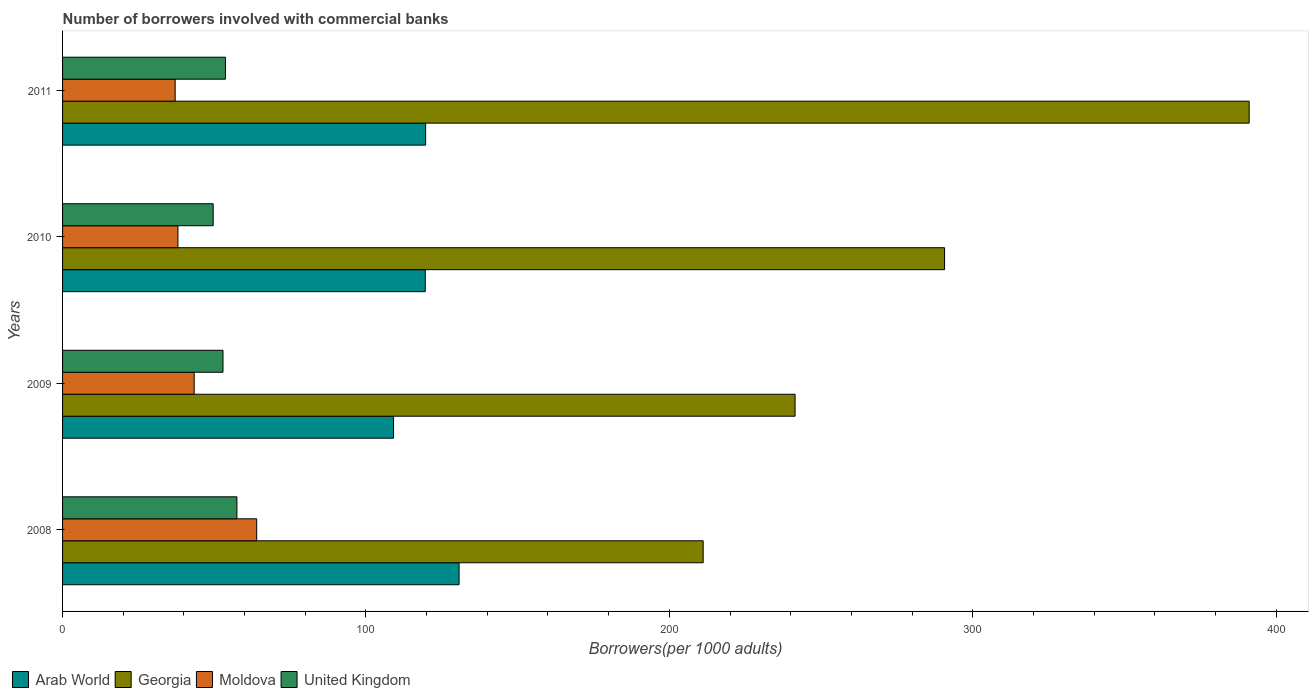How many different coloured bars are there?
Provide a short and direct response. 4. How many groups of bars are there?
Your answer should be very brief. 4. Are the number of bars on each tick of the Y-axis equal?
Your answer should be compact. Yes. How many bars are there on the 1st tick from the top?
Provide a succinct answer. 4. What is the label of the 2nd group of bars from the top?
Offer a very short reply. 2010. What is the number of borrowers involved with commercial banks in Georgia in 2009?
Provide a short and direct response. 241.45. Across all years, what is the maximum number of borrowers involved with commercial banks in Georgia?
Give a very brief answer. 391.13. Across all years, what is the minimum number of borrowers involved with commercial banks in Moldova?
Provide a short and direct response. 37.11. In which year was the number of borrowers involved with commercial banks in Georgia maximum?
Keep it short and to the point. 2011. What is the total number of borrowers involved with commercial banks in Georgia in the graph?
Make the answer very short. 1134.46. What is the difference between the number of borrowers involved with commercial banks in Arab World in 2010 and that in 2011?
Offer a very short reply. -0.13. What is the difference between the number of borrowers involved with commercial banks in Georgia in 2010 and the number of borrowers involved with commercial banks in Moldova in 2009?
Your answer should be compact. 247.35. What is the average number of borrowers involved with commercial banks in Moldova per year?
Your answer should be compact. 45.63. In the year 2010, what is the difference between the number of borrowers involved with commercial banks in Moldova and number of borrowers involved with commercial banks in Georgia?
Offer a terse response. -252.69. What is the ratio of the number of borrowers involved with commercial banks in Moldova in 2010 to that in 2011?
Your answer should be very brief. 1.02. Is the difference between the number of borrowers involved with commercial banks in Moldova in 2008 and 2010 greater than the difference between the number of borrowers involved with commercial banks in Georgia in 2008 and 2010?
Give a very brief answer. Yes. What is the difference between the highest and the second highest number of borrowers involved with commercial banks in Moldova?
Make the answer very short. 20.61. What is the difference between the highest and the lowest number of borrowers involved with commercial banks in Georgia?
Keep it short and to the point. 179.97. In how many years, is the number of borrowers involved with commercial banks in United Kingdom greater than the average number of borrowers involved with commercial banks in United Kingdom taken over all years?
Make the answer very short. 2. Is the sum of the number of borrowers involved with commercial banks in Georgia in 2008 and 2011 greater than the maximum number of borrowers involved with commercial banks in Arab World across all years?
Provide a succinct answer. Yes. What does the 3rd bar from the top in 2011 represents?
Offer a terse response. Georgia. What does the 2nd bar from the bottom in 2008 represents?
Offer a very short reply. Georgia. How many years are there in the graph?
Ensure brevity in your answer.  4. What is the difference between two consecutive major ticks on the X-axis?
Your answer should be very brief. 100. Does the graph contain any zero values?
Give a very brief answer. No. Does the graph contain grids?
Give a very brief answer. No. Where does the legend appear in the graph?
Your response must be concise. Bottom left. How many legend labels are there?
Your answer should be very brief. 4. What is the title of the graph?
Your answer should be compact. Number of borrowers involved with commercial banks. What is the label or title of the X-axis?
Ensure brevity in your answer.  Borrowers(per 1000 adults). What is the label or title of the Y-axis?
Keep it short and to the point. Years. What is the Borrowers(per 1000 adults) in Arab World in 2008?
Offer a terse response. 130.7. What is the Borrowers(per 1000 adults) of Georgia in 2008?
Keep it short and to the point. 211.16. What is the Borrowers(per 1000 adults) of Moldova in 2008?
Provide a succinct answer. 63.99. What is the Borrowers(per 1000 adults) in United Kingdom in 2008?
Ensure brevity in your answer.  57.47. What is the Borrowers(per 1000 adults) of Arab World in 2009?
Offer a very short reply. 109.1. What is the Borrowers(per 1000 adults) of Georgia in 2009?
Keep it short and to the point. 241.45. What is the Borrowers(per 1000 adults) of Moldova in 2009?
Ensure brevity in your answer.  43.38. What is the Borrowers(per 1000 adults) of United Kingdom in 2009?
Your response must be concise. 52.88. What is the Borrowers(per 1000 adults) of Arab World in 2010?
Keep it short and to the point. 119.55. What is the Borrowers(per 1000 adults) of Georgia in 2010?
Your response must be concise. 290.72. What is the Borrowers(per 1000 adults) in Moldova in 2010?
Your answer should be compact. 38.03. What is the Borrowers(per 1000 adults) in United Kingdom in 2010?
Offer a terse response. 49.65. What is the Borrowers(per 1000 adults) in Arab World in 2011?
Your answer should be very brief. 119.68. What is the Borrowers(per 1000 adults) of Georgia in 2011?
Your response must be concise. 391.13. What is the Borrowers(per 1000 adults) of Moldova in 2011?
Give a very brief answer. 37.11. What is the Borrowers(per 1000 adults) in United Kingdom in 2011?
Offer a very short reply. 53.68. Across all years, what is the maximum Borrowers(per 1000 adults) of Arab World?
Provide a succinct answer. 130.7. Across all years, what is the maximum Borrowers(per 1000 adults) in Georgia?
Your response must be concise. 391.13. Across all years, what is the maximum Borrowers(per 1000 adults) in Moldova?
Your response must be concise. 63.99. Across all years, what is the maximum Borrowers(per 1000 adults) in United Kingdom?
Provide a succinct answer. 57.47. Across all years, what is the minimum Borrowers(per 1000 adults) in Arab World?
Make the answer very short. 109.1. Across all years, what is the minimum Borrowers(per 1000 adults) in Georgia?
Offer a terse response. 211.16. Across all years, what is the minimum Borrowers(per 1000 adults) in Moldova?
Your response must be concise. 37.11. Across all years, what is the minimum Borrowers(per 1000 adults) in United Kingdom?
Make the answer very short. 49.65. What is the total Borrowers(per 1000 adults) of Arab World in the graph?
Provide a short and direct response. 479.02. What is the total Borrowers(per 1000 adults) in Georgia in the graph?
Provide a succinct answer. 1134.46. What is the total Borrowers(per 1000 adults) of Moldova in the graph?
Your response must be concise. 182.52. What is the total Borrowers(per 1000 adults) of United Kingdom in the graph?
Your answer should be compact. 213.68. What is the difference between the Borrowers(per 1000 adults) of Arab World in 2008 and that in 2009?
Ensure brevity in your answer.  21.6. What is the difference between the Borrowers(per 1000 adults) in Georgia in 2008 and that in 2009?
Your answer should be very brief. -30.29. What is the difference between the Borrowers(per 1000 adults) of Moldova in 2008 and that in 2009?
Your answer should be compact. 20.61. What is the difference between the Borrowers(per 1000 adults) in United Kingdom in 2008 and that in 2009?
Offer a terse response. 4.59. What is the difference between the Borrowers(per 1000 adults) of Arab World in 2008 and that in 2010?
Ensure brevity in your answer.  11.15. What is the difference between the Borrowers(per 1000 adults) in Georgia in 2008 and that in 2010?
Give a very brief answer. -79.56. What is the difference between the Borrowers(per 1000 adults) of Moldova in 2008 and that in 2010?
Offer a terse response. 25.95. What is the difference between the Borrowers(per 1000 adults) of United Kingdom in 2008 and that in 2010?
Keep it short and to the point. 7.83. What is the difference between the Borrowers(per 1000 adults) of Arab World in 2008 and that in 2011?
Give a very brief answer. 11.02. What is the difference between the Borrowers(per 1000 adults) in Georgia in 2008 and that in 2011?
Ensure brevity in your answer.  -179.97. What is the difference between the Borrowers(per 1000 adults) in Moldova in 2008 and that in 2011?
Offer a very short reply. 26.87. What is the difference between the Borrowers(per 1000 adults) of United Kingdom in 2008 and that in 2011?
Your answer should be very brief. 3.79. What is the difference between the Borrowers(per 1000 adults) of Arab World in 2009 and that in 2010?
Offer a terse response. -10.45. What is the difference between the Borrowers(per 1000 adults) of Georgia in 2009 and that in 2010?
Provide a short and direct response. -49.27. What is the difference between the Borrowers(per 1000 adults) of Moldova in 2009 and that in 2010?
Offer a terse response. 5.34. What is the difference between the Borrowers(per 1000 adults) of United Kingdom in 2009 and that in 2010?
Provide a short and direct response. 3.23. What is the difference between the Borrowers(per 1000 adults) of Arab World in 2009 and that in 2011?
Keep it short and to the point. -10.58. What is the difference between the Borrowers(per 1000 adults) of Georgia in 2009 and that in 2011?
Your response must be concise. -149.68. What is the difference between the Borrowers(per 1000 adults) of Moldova in 2009 and that in 2011?
Your answer should be very brief. 6.26. What is the difference between the Borrowers(per 1000 adults) in United Kingdom in 2009 and that in 2011?
Make the answer very short. -0.8. What is the difference between the Borrowers(per 1000 adults) in Arab World in 2010 and that in 2011?
Keep it short and to the point. -0.13. What is the difference between the Borrowers(per 1000 adults) of Georgia in 2010 and that in 2011?
Your answer should be very brief. -100.4. What is the difference between the Borrowers(per 1000 adults) of Moldova in 2010 and that in 2011?
Your response must be concise. 0.92. What is the difference between the Borrowers(per 1000 adults) of United Kingdom in 2010 and that in 2011?
Give a very brief answer. -4.03. What is the difference between the Borrowers(per 1000 adults) in Arab World in 2008 and the Borrowers(per 1000 adults) in Georgia in 2009?
Your answer should be compact. -110.75. What is the difference between the Borrowers(per 1000 adults) in Arab World in 2008 and the Borrowers(per 1000 adults) in Moldova in 2009?
Make the answer very short. 87.32. What is the difference between the Borrowers(per 1000 adults) of Arab World in 2008 and the Borrowers(per 1000 adults) of United Kingdom in 2009?
Provide a short and direct response. 77.82. What is the difference between the Borrowers(per 1000 adults) in Georgia in 2008 and the Borrowers(per 1000 adults) in Moldova in 2009?
Your answer should be compact. 167.78. What is the difference between the Borrowers(per 1000 adults) in Georgia in 2008 and the Borrowers(per 1000 adults) in United Kingdom in 2009?
Offer a terse response. 158.28. What is the difference between the Borrowers(per 1000 adults) in Moldova in 2008 and the Borrowers(per 1000 adults) in United Kingdom in 2009?
Ensure brevity in your answer.  11.11. What is the difference between the Borrowers(per 1000 adults) in Arab World in 2008 and the Borrowers(per 1000 adults) in Georgia in 2010?
Ensure brevity in your answer.  -160.03. What is the difference between the Borrowers(per 1000 adults) of Arab World in 2008 and the Borrowers(per 1000 adults) of Moldova in 2010?
Provide a short and direct response. 92.66. What is the difference between the Borrowers(per 1000 adults) of Arab World in 2008 and the Borrowers(per 1000 adults) of United Kingdom in 2010?
Your answer should be compact. 81.05. What is the difference between the Borrowers(per 1000 adults) in Georgia in 2008 and the Borrowers(per 1000 adults) in Moldova in 2010?
Your answer should be compact. 173.12. What is the difference between the Borrowers(per 1000 adults) in Georgia in 2008 and the Borrowers(per 1000 adults) in United Kingdom in 2010?
Ensure brevity in your answer.  161.51. What is the difference between the Borrowers(per 1000 adults) of Moldova in 2008 and the Borrowers(per 1000 adults) of United Kingdom in 2010?
Your response must be concise. 14.34. What is the difference between the Borrowers(per 1000 adults) of Arab World in 2008 and the Borrowers(per 1000 adults) of Georgia in 2011?
Make the answer very short. -260.43. What is the difference between the Borrowers(per 1000 adults) in Arab World in 2008 and the Borrowers(per 1000 adults) in Moldova in 2011?
Ensure brevity in your answer.  93.58. What is the difference between the Borrowers(per 1000 adults) of Arab World in 2008 and the Borrowers(per 1000 adults) of United Kingdom in 2011?
Your answer should be compact. 77.02. What is the difference between the Borrowers(per 1000 adults) of Georgia in 2008 and the Borrowers(per 1000 adults) of Moldova in 2011?
Your answer should be very brief. 174.05. What is the difference between the Borrowers(per 1000 adults) in Georgia in 2008 and the Borrowers(per 1000 adults) in United Kingdom in 2011?
Provide a short and direct response. 157.48. What is the difference between the Borrowers(per 1000 adults) in Moldova in 2008 and the Borrowers(per 1000 adults) in United Kingdom in 2011?
Give a very brief answer. 10.31. What is the difference between the Borrowers(per 1000 adults) of Arab World in 2009 and the Borrowers(per 1000 adults) of Georgia in 2010?
Ensure brevity in your answer.  -181.63. What is the difference between the Borrowers(per 1000 adults) of Arab World in 2009 and the Borrowers(per 1000 adults) of Moldova in 2010?
Ensure brevity in your answer.  71.06. What is the difference between the Borrowers(per 1000 adults) of Arab World in 2009 and the Borrowers(per 1000 adults) of United Kingdom in 2010?
Your response must be concise. 59.45. What is the difference between the Borrowers(per 1000 adults) of Georgia in 2009 and the Borrowers(per 1000 adults) of Moldova in 2010?
Offer a very short reply. 203.42. What is the difference between the Borrowers(per 1000 adults) in Georgia in 2009 and the Borrowers(per 1000 adults) in United Kingdom in 2010?
Your answer should be compact. 191.8. What is the difference between the Borrowers(per 1000 adults) of Moldova in 2009 and the Borrowers(per 1000 adults) of United Kingdom in 2010?
Offer a terse response. -6.27. What is the difference between the Borrowers(per 1000 adults) of Arab World in 2009 and the Borrowers(per 1000 adults) of Georgia in 2011?
Your answer should be very brief. -282.03. What is the difference between the Borrowers(per 1000 adults) in Arab World in 2009 and the Borrowers(per 1000 adults) in Moldova in 2011?
Provide a succinct answer. 71.98. What is the difference between the Borrowers(per 1000 adults) of Arab World in 2009 and the Borrowers(per 1000 adults) of United Kingdom in 2011?
Ensure brevity in your answer.  55.42. What is the difference between the Borrowers(per 1000 adults) of Georgia in 2009 and the Borrowers(per 1000 adults) of Moldova in 2011?
Make the answer very short. 204.34. What is the difference between the Borrowers(per 1000 adults) of Georgia in 2009 and the Borrowers(per 1000 adults) of United Kingdom in 2011?
Provide a succinct answer. 187.77. What is the difference between the Borrowers(per 1000 adults) of Moldova in 2009 and the Borrowers(per 1000 adults) of United Kingdom in 2011?
Offer a very short reply. -10.3. What is the difference between the Borrowers(per 1000 adults) in Arab World in 2010 and the Borrowers(per 1000 adults) in Georgia in 2011?
Ensure brevity in your answer.  -271.58. What is the difference between the Borrowers(per 1000 adults) of Arab World in 2010 and the Borrowers(per 1000 adults) of Moldova in 2011?
Keep it short and to the point. 82.43. What is the difference between the Borrowers(per 1000 adults) of Arab World in 2010 and the Borrowers(per 1000 adults) of United Kingdom in 2011?
Offer a very short reply. 65.87. What is the difference between the Borrowers(per 1000 adults) of Georgia in 2010 and the Borrowers(per 1000 adults) of Moldova in 2011?
Give a very brief answer. 253.61. What is the difference between the Borrowers(per 1000 adults) of Georgia in 2010 and the Borrowers(per 1000 adults) of United Kingdom in 2011?
Offer a very short reply. 237.04. What is the difference between the Borrowers(per 1000 adults) of Moldova in 2010 and the Borrowers(per 1000 adults) of United Kingdom in 2011?
Offer a very short reply. -15.64. What is the average Borrowers(per 1000 adults) of Arab World per year?
Offer a terse response. 119.76. What is the average Borrowers(per 1000 adults) in Georgia per year?
Your answer should be very brief. 283.62. What is the average Borrowers(per 1000 adults) in Moldova per year?
Your answer should be compact. 45.63. What is the average Borrowers(per 1000 adults) of United Kingdom per year?
Give a very brief answer. 53.42. In the year 2008, what is the difference between the Borrowers(per 1000 adults) in Arab World and Borrowers(per 1000 adults) in Georgia?
Your answer should be very brief. -80.46. In the year 2008, what is the difference between the Borrowers(per 1000 adults) in Arab World and Borrowers(per 1000 adults) in Moldova?
Your answer should be very brief. 66.71. In the year 2008, what is the difference between the Borrowers(per 1000 adults) in Arab World and Borrowers(per 1000 adults) in United Kingdom?
Keep it short and to the point. 73.22. In the year 2008, what is the difference between the Borrowers(per 1000 adults) in Georgia and Borrowers(per 1000 adults) in Moldova?
Give a very brief answer. 147.17. In the year 2008, what is the difference between the Borrowers(per 1000 adults) of Georgia and Borrowers(per 1000 adults) of United Kingdom?
Provide a short and direct response. 153.69. In the year 2008, what is the difference between the Borrowers(per 1000 adults) of Moldova and Borrowers(per 1000 adults) of United Kingdom?
Your answer should be very brief. 6.52. In the year 2009, what is the difference between the Borrowers(per 1000 adults) in Arab World and Borrowers(per 1000 adults) in Georgia?
Your response must be concise. -132.35. In the year 2009, what is the difference between the Borrowers(per 1000 adults) of Arab World and Borrowers(per 1000 adults) of Moldova?
Provide a succinct answer. 65.72. In the year 2009, what is the difference between the Borrowers(per 1000 adults) in Arab World and Borrowers(per 1000 adults) in United Kingdom?
Provide a short and direct response. 56.22. In the year 2009, what is the difference between the Borrowers(per 1000 adults) of Georgia and Borrowers(per 1000 adults) of Moldova?
Provide a short and direct response. 198.07. In the year 2009, what is the difference between the Borrowers(per 1000 adults) in Georgia and Borrowers(per 1000 adults) in United Kingdom?
Offer a very short reply. 188.57. In the year 2009, what is the difference between the Borrowers(per 1000 adults) in Moldova and Borrowers(per 1000 adults) in United Kingdom?
Your answer should be compact. -9.5. In the year 2010, what is the difference between the Borrowers(per 1000 adults) of Arab World and Borrowers(per 1000 adults) of Georgia?
Ensure brevity in your answer.  -171.17. In the year 2010, what is the difference between the Borrowers(per 1000 adults) of Arab World and Borrowers(per 1000 adults) of Moldova?
Your response must be concise. 81.51. In the year 2010, what is the difference between the Borrowers(per 1000 adults) in Arab World and Borrowers(per 1000 adults) in United Kingdom?
Provide a short and direct response. 69.9. In the year 2010, what is the difference between the Borrowers(per 1000 adults) of Georgia and Borrowers(per 1000 adults) of Moldova?
Your response must be concise. 252.69. In the year 2010, what is the difference between the Borrowers(per 1000 adults) of Georgia and Borrowers(per 1000 adults) of United Kingdom?
Your answer should be very brief. 241.07. In the year 2010, what is the difference between the Borrowers(per 1000 adults) in Moldova and Borrowers(per 1000 adults) in United Kingdom?
Your answer should be very brief. -11.61. In the year 2011, what is the difference between the Borrowers(per 1000 adults) of Arab World and Borrowers(per 1000 adults) of Georgia?
Offer a very short reply. -271.45. In the year 2011, what is the difference between the Borrowers(per 1000 adults) in Arab World and Borrowers(per 1000 adults) in Moldova?
Ensure brevity in your answer.  82.57. In the year 2011, what is the difference between the Borrowers(per 1000 adults) of Arab World and Borrowers(per 1000 adults) of United Kingdom?
Make the answer very short. 66. In the year 2011, what is the difference between the Borrowers(per 1000 adults) in Georgia and Borrowers(per 1000 adults) in Moldova?
Offer a very short reply. 354.01. In the year 2011, what is the difference between the Borrowers(per 1000 adults) of Georgia and Borrowers(per 1000 adults) of United Kingdom?
Your response must be concise. 337.45. In the year 2011, what is the difference between the Borrowers(per 1000 adults) of Moldova and Borrowers(per 1000 adults) of United Kingdom?
Your answer should be compact. -16.57. What is the ratio of the Borrowers(per 1000 adults) in Arab World in 2008 to that in 2009?
Your response must be concise. 1.2. What is the ratio of the Borrowers(per 1000 adults) in Georgia in 2008 to that in 2009?
Your answer should be compact. 0.87. What is the ratio of the Borrowers(per 1000 adults) of Moldova in 2008 to that in 2009?
Your answer should be compact. 1.48. What is the ratio of the Borrowers(per 1000 adults) of United Kingdom in 2008 to that in 2009?
Offer a terse response. 1.09. What is the ratio of the Borrowers(per 1000 adults) in Arab World in 2008 to that in 2010?
Your answer should be very brief. 1.09. What is the ratio of the Borrowers(per 1000 adults) in Georgia in 2008 to that in 2010?
Your response must be concise. 0.73. What is the ratio of the Borrowers(per 1000 adults) of Moldova in 2008 to that in 2010?
Make the answer very short. 1.68. What is the ratio of the Borrowers(per 1000 adults) in United Kingdom in 2008 to that in 2010?
Ensure brevity in your answer.  1.16. What is the ratio of the Borrowers(per 1000 adults) of Arab World in 2008 to that in 2011?
Your response must be concise. 1.09. What is the ratio of the Borrowers(per 1000 adults) in Georgia in 2008 to that in 2011?
Your answer should be very brief. 0.54. What is the ratio of the Borrowers(per 1000 adults) of Moldova in 2008 to that in 2011?
Provide a succinct answer. 1.72. What is the ratio of the Borrowers(per 1000 adults) in United Kingdom in 2008 to that in 2011?
Provide a short and direct response. 1.07. What is the ratio of the Borrowers(per 1000 adults) of Arab World in 2009 to that in 2010?
Your response must be concise. 0.91. What is the ratio of the Borrowers(per 1000 adults) in Georgia in 2009 to that in 2010?
Your answer should be very brief. 0.83. What is the ratio of the Borrowers(per 1000 adults) of Moldova in 2009 to that in 2010?
Your answer should be compact. 1.14. What is the ratio of the Borrowers(per 1000 adults) in United Kingdom in 2009 to that in 2010?
Offer a very short reply. 1.07. What is the ratio of the Borrowers(per 1000 adults) of Arab World in 2009 to that in 2011?
Offer a very short reply. 0.91. What is the ratio of the Borrowers(per 1000 adults) in Georgia in 2009 to that in 2011?
Your answer should be compact. 0.62. What is the ratio of the Borrowers(per 1000 adults) of Moldova in 2009 to that in 2011?
Your answer should be very brief. 1.17. What is the ratio of the Borrowers(per 1000 adults) in United Kingdom in 2009 to that in 2011?
Give a very brief answer. 0.99. What is the ratio of the Borrowers(per 1000 adults) in Georgia in 2010 to that in 2011?
Keep it short and to the point. 0.74. What is the ratio of the Borrowers(per 1000 adults) of Moldova in 2010 to that in 2011?
Your answer should be compact. 1.02. What is the ratio of the Borrowers(per 1000 adults) in United Kingdom in 2010 to that in 2011?
Provide a short and direct response. 0.92. What is the difference between the highest and the second highest Borrowers(per 1000 adults) of Arab World?
Keep it short and to the point. 11.02. What is the difference between the highest and the second highest Borrowers(per 1000 adults) of Georgia?
Give a very brief answer. 100.4. What is the difference between the highest and the second highest Borrowers(per 1000 adults) in Moldova?
Your answer should be very brief. 20.61. What is the difference between the highest and the second highest Borrowers(per 1000 adults) of United Kingdom?
Your answer should be compact. 3.79. What is the difference between the highest and the lowest Borrowers(per 1000 adults) of Arab World?
Your answer should be very brief. 21.6. What is the difference between the highest and the lowest Borrowers(per 1000 adults) of Georgia?
Keep it short and to the point. 179.97. What is the difference between the highest and the lowest Borrowers(per 1000 adults) of Moldova?
Your answer should be compact. 26.87. What is the difference between the highest and the lowest Borrowers(per 1000 adults) in United Kingdom?
Provide a short and direct response. 7.83. 